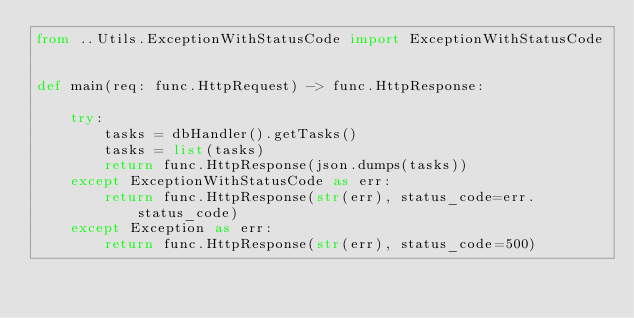Convert code to text. <code><loc_0><loc_0><loc_500><loc_500><_Python_>from ..Utils.ExceptionWithStatusCode import ExceptionWithStatusCode


def main(req: func.HttpRequest) -> func.HttpResponse:

    try:
        tasks = dbHandler().getTasks()
        tasks = list(tasks)
        return func.HttpResponse(json.dumps(tasks))
    except ExceptionWithStatusCode as err:
        return func.HttpResponse(str(err), status_code=err.status_code)
    except Exception as err:
        return func.HttpResponse(str(err), status_code=500)</code> 